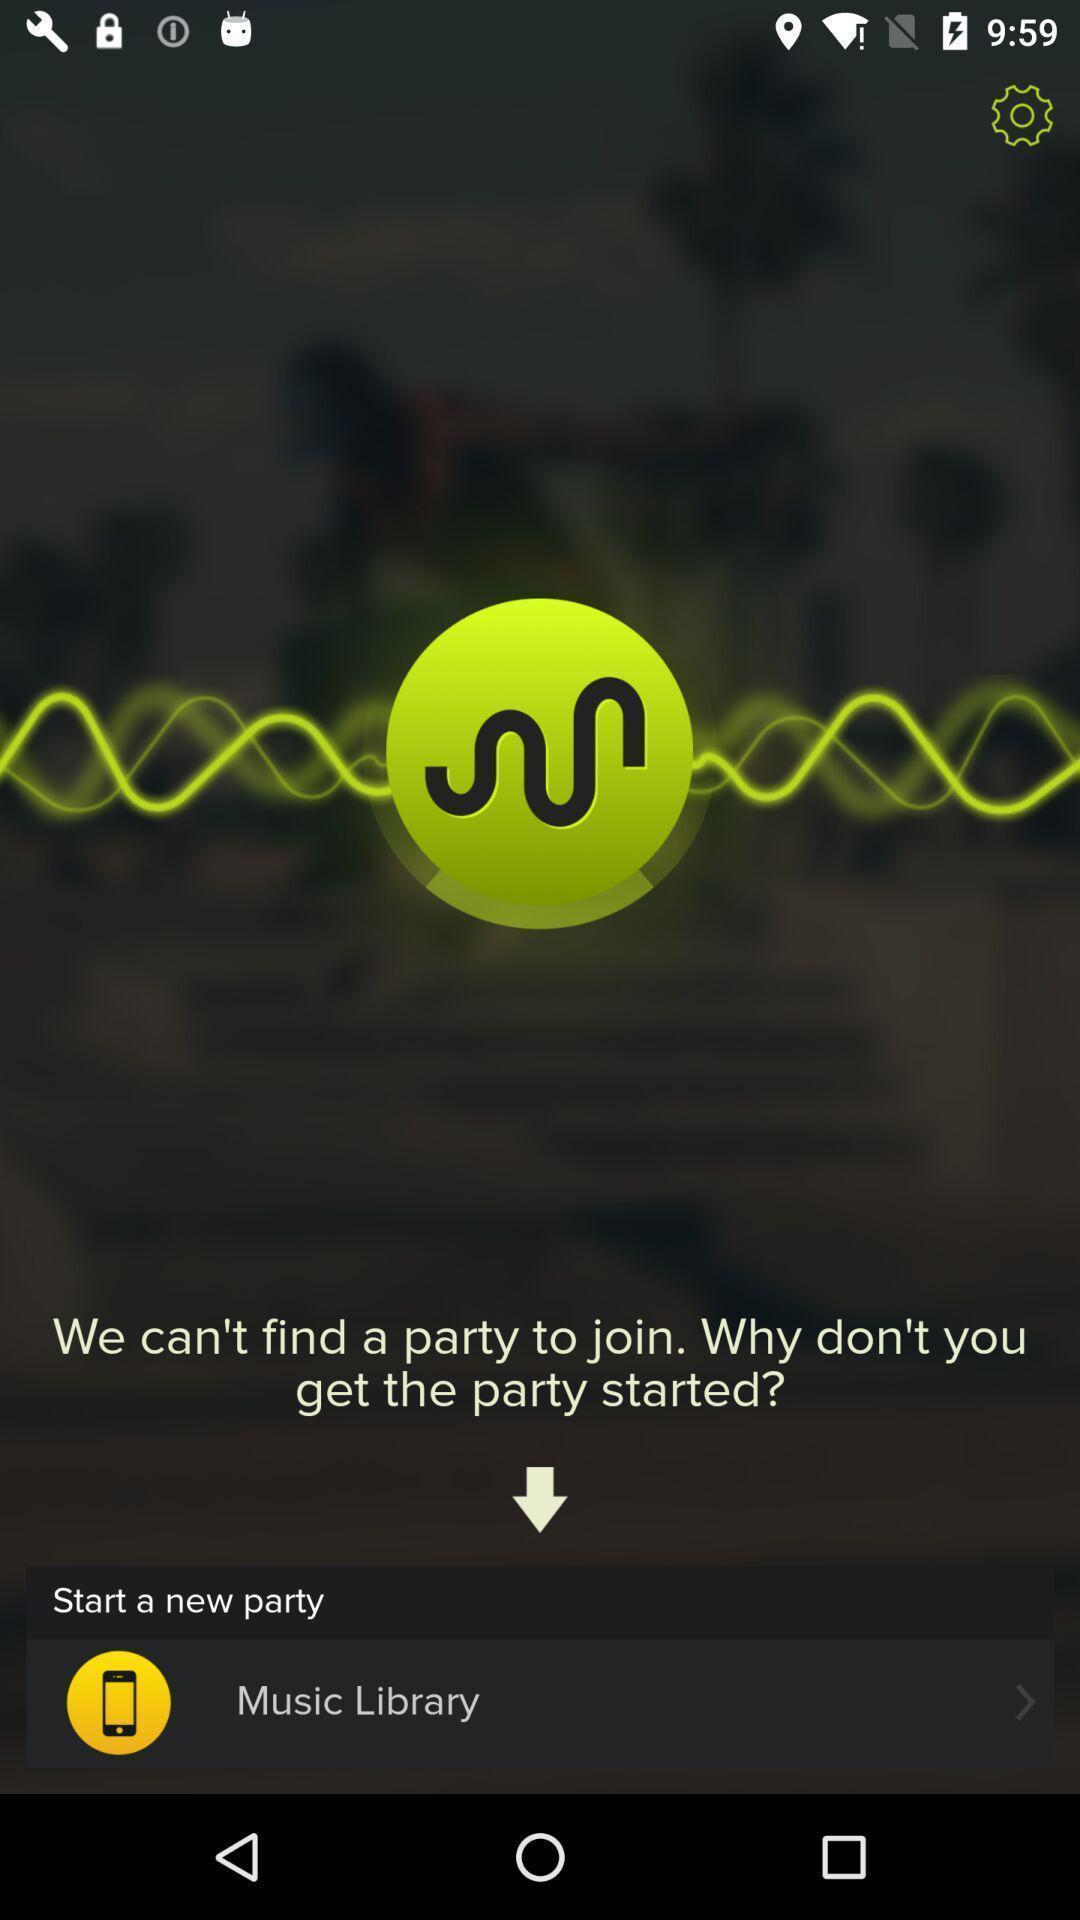Explain what's happening in this screen capture. Screen shows the music application. 